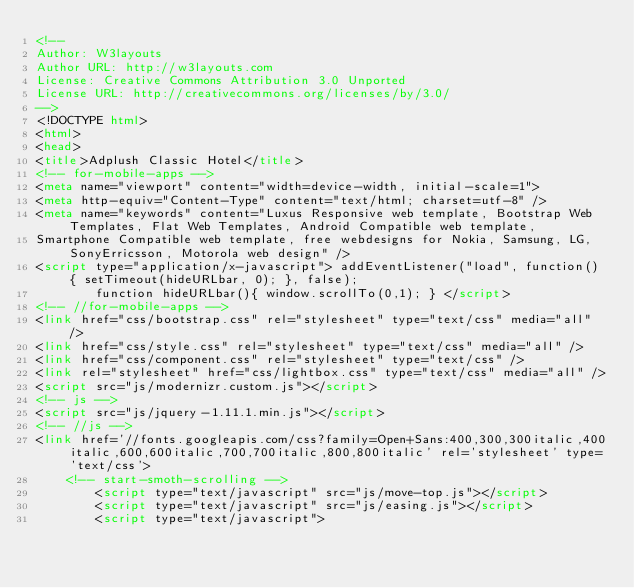Convert code to text. <code><loc_0><loc_0><loc_500><loc_500><_HTML_><!--
Author: W3layouts
Author URL: http://w3layouts.com
License: Creative Commons Attribution 3.0 Unported
License URL: http://creativecommons.org/licenses/by/3.0/
-->
<!DOCTYPE html>
<html>
<head>
<title>Adplush Classic Hotel</title>
<!-- for-mobile-apps -->
<meta name="viewport" content="width=device-width, initial-scale=1">
<meta http-equiv="Content-Type" content="text/html; charset=utf-8" />
<meta name="keywords" content="Luxus Responsive web template, Bootstrap Web Templates, Flat Web Templates, Android Compatible web template, 
Smartphone Compatible web template, free webdesigns for Nokia, Samsung, LG, SonyErricsson, Motorola web design" />
<script type="application/x-javascript"> addEventListener("load", function() { setTimeout(hideURLbar, 0); }, false);
		function hideURLbar(){ window.scrollTo(0,1); } </script>
<!-- //for-mobile-apps -->
<link href="css/bootstrap.css" rel="stylesheet" type="text/css" media="all" />
<link href="css/style.css" rel="stylesheet" type="text/css" media="all" />
<link href="css/component.css" rel="stylesheet" type="text/css" />
<link rel="stylesheet" href="css/lightbox.css" type="text/css" media="all" />
<script src="js/modernizr.custom.js"></script>
<!-- js -->
<script src="js/jquery-1.11.1.min.js"></script>
<!-- //js -->
<link href='//fonts.googleapis.com/css?family=Open+Sans:400,300,300italic,400italic,600,600italic,700,700italic,800,800italic' rel='stylesheet' type='text/css'>
	<!-- start-smoth-scrolling -->
		<script type="text/javascript" src="js/move-top.js"></script>
		<script type="text/javascript" src="js/easing.js"></script>
		<script type="text/javascript"></code> 